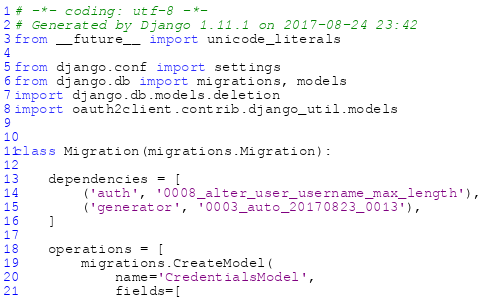Convert code to text. <code><loc_0><loc_0><loc_500><loc_500><_Python_># -*- coding: utf-8 -*-
# Generated by Django 1.11.1 on 2017-08-24 23:42
from __future__ import unicode_literals

from django.conf import settings
from django.db import migrations, models
import django.db.models.deletion
import oauth2client.contrib.django_util.models


class Migration(migrations.Migration):

    dependencies = [
        ('auth', '0008_alter_user_username_max_length'),
        ('generator', '0003_auto_20170823_0013'),
    ]

    operations = [
        migrations.CreateModel(
            name='CredentialsModel',
            fields=[</code> 